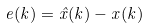<formula> <loc_0><loc_0><loc_500><loc_500>e ( k ) = \hat { x } ( k ) - x ( k )</formula> 